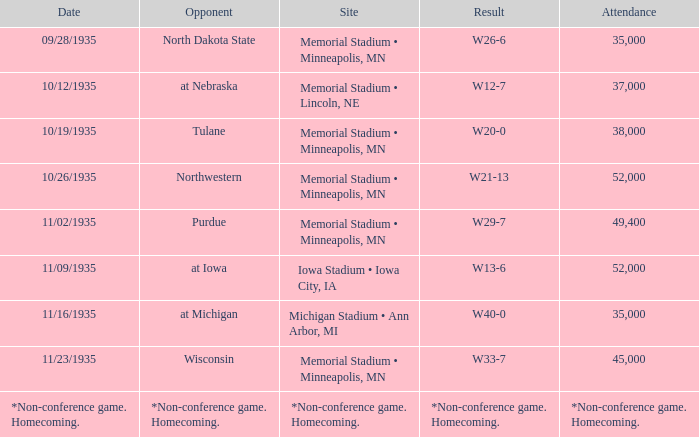What was the attendance count for the game held on november 9, 1935? 52000.0. 